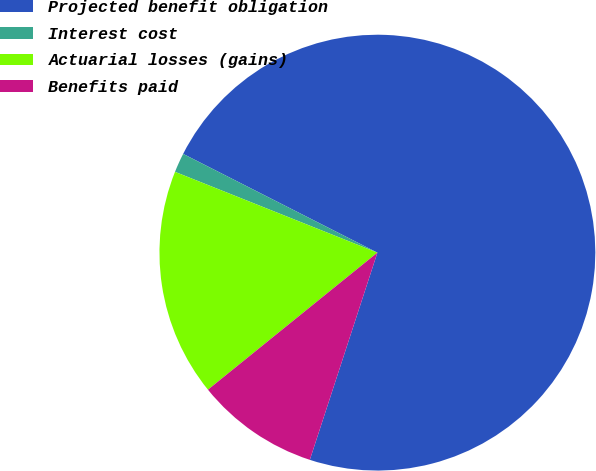<chart> <loc_0><loc_0><loc_500><loc_500><pie_chart><fcel>Projected benefit obligation<fcel>Interest cost<fcel>Actuarial losses (gains)<fcel>Benefits paid<nl><fcel>72.53%<fcel>1.44%<fcel>16.87%<fcel>9.16%<nl></chart> 